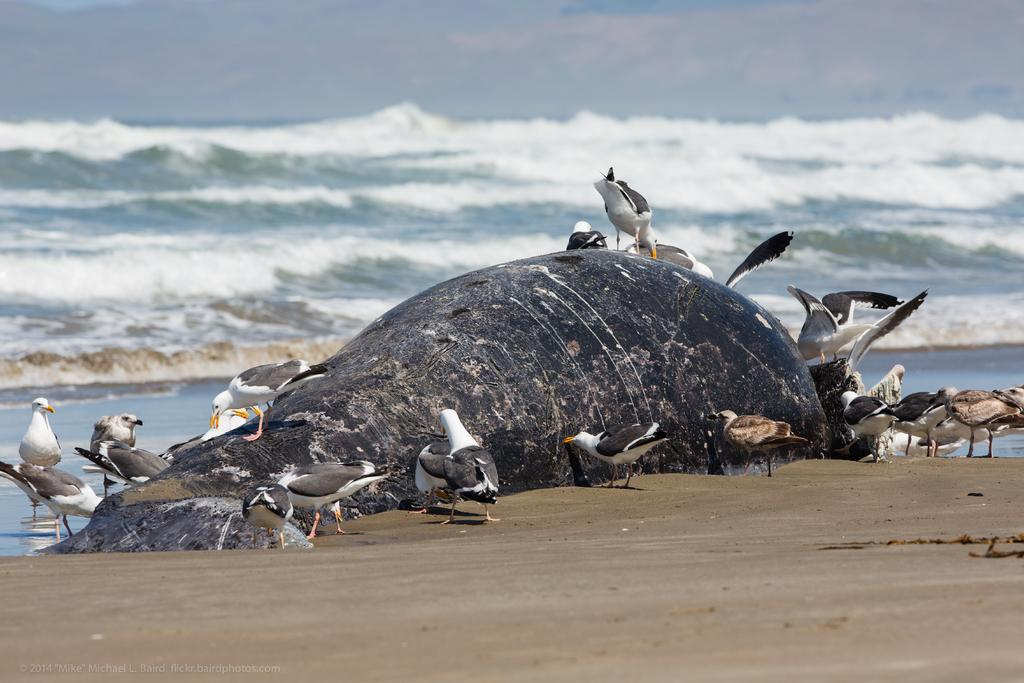What type of surface can be seen in the image? The ground is visible in the image. What animals are present in the image? There is a fish and birds in the image. What is visible in the background of the image? There is water visible in the background of the image. What type of cracker is being used to feed the snow in the image? There is no cracker or snow present in the image. In which month was the image taken? The provided facts do not mention a specific month, so it cannot be determined from the image. 